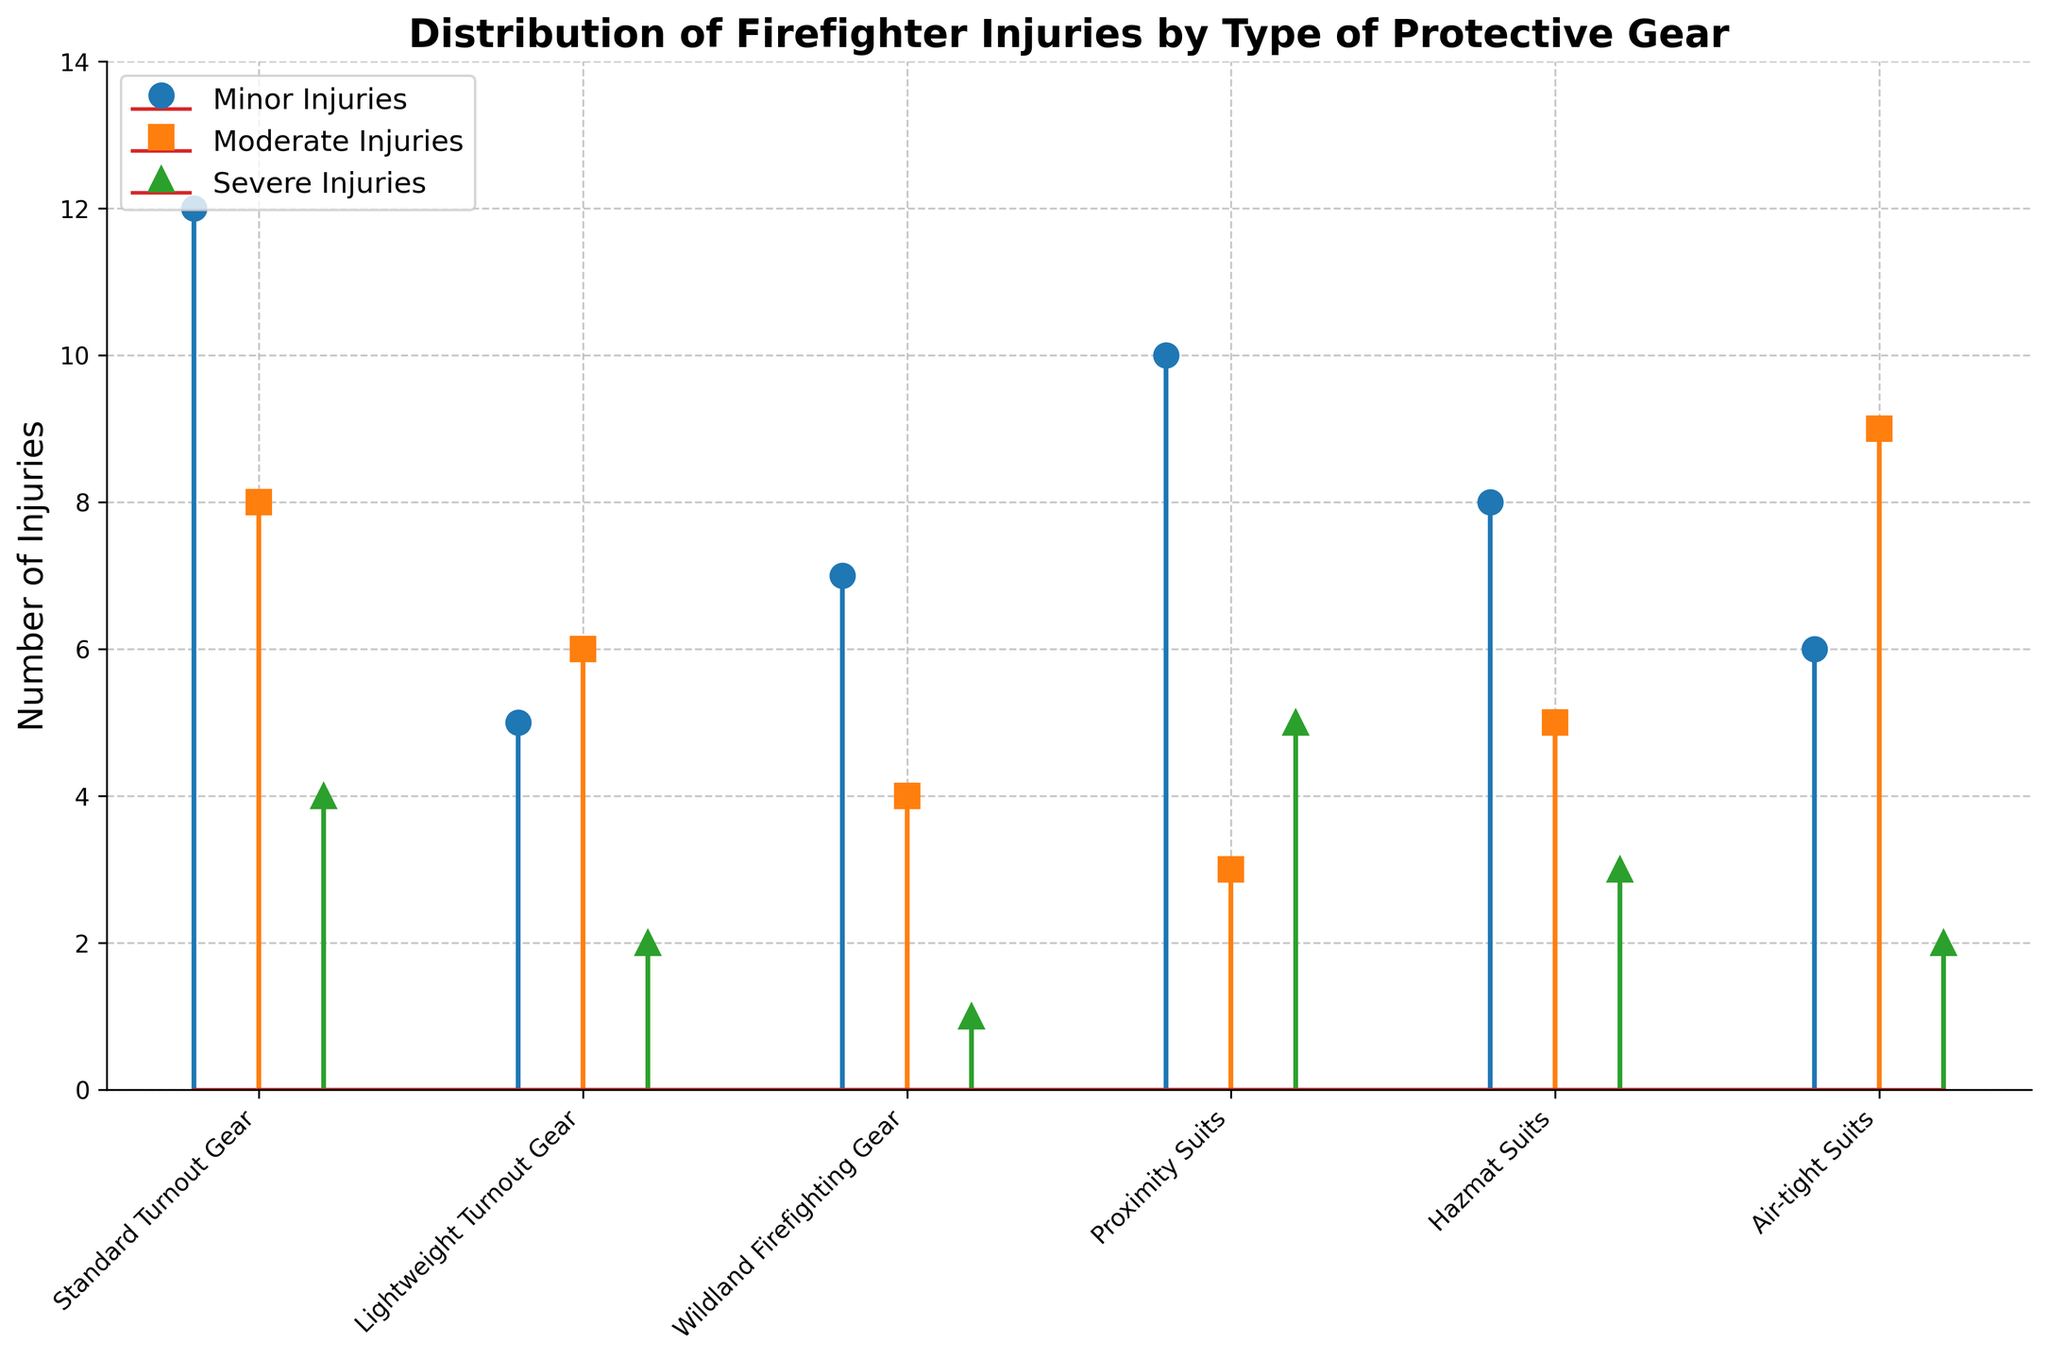How many gear types are compared in the figure? The X-axis of the stem plot has labels for each gear type compared in the figure. Counting the labels gives the total number of gear types.
Answer: 6 Which type of injury is represented by the squares? The legend in the figure indicates the type of injuries represented by different symbols. Squares correspond to moderate injuries.
Answer: Moderate Injuries Which protective gear has the highest number of minor injuries? In the stem plot, the number of minor injuries for each gear type is shown by the left-most marker in each set. By comparing the heights of the left-most markers, the gear with the highest value can be identified.
Answer: Standard Turnout Gear What is the total number of severe injuries for all gear types combined? Add the severe injury values for each gear type: 4 (Standard Turnout Gear) + 2 (Lightweight Turnout Gear) + 1 (Wildland Firefighting Gear) + 5 (Proximity Suits) + 3 (Hazmat Suits) + 2 (Air-tight Suits).
Answer: 17 Which two protective gears have the same number of severe injuries? Look for positions where the markers indicating severe injuries have the same height. Both Lightweight Turnout Gear and Air-tight Suits have markers at the same height.
Answer: Lightweight Turnout Gear and Air-tight Suits How many more moderate injuries are there in Air-tight Suits compared to Proximity Suits? Subtract the number of moderate injuries in Proximity Suits (3) from the number of moderate injuries in Air-tight Suits (9).
Answer: 6 Which protective gear has the least total number of injuries (all types combined)? Sum the injury counts of each type (minor, moderate, and severe) for each gear type and compare them. Wildland Firefighting Gear has 7 + 4 + 1 = 12, which is the smallest total.
Answer: Wildland Firefighting Gear How does the number of moderate injuries in Hazmat Suits compare to the number of minor injuries in Lightweight Turnout Gear? Compare the moderate injuries in Hazmat Suits (5) with the minor injuries in Lightweight Turnout Gear (5). They are equal.
Answer: Equal Which gear has a higher ratio of moderate to severe injuries, Proximity Suits or Air-tight Suits? Calculate the ratio of moderate to severe injuries for each gear: Proximity Suits have 3/5 = 0.6 and Air-tight Suits have 9/2 = 4.5. Air-tight Suits have a higher ratio.
Answer: Air-tight Suits What is the average number of injuries per type for Standard Turnout Gear? Add the minor (12), moderate (8), and severe (4) injuries and divide by 3. The average is (12 + 8 + 4) / 3 = 8.
Answer: 8 